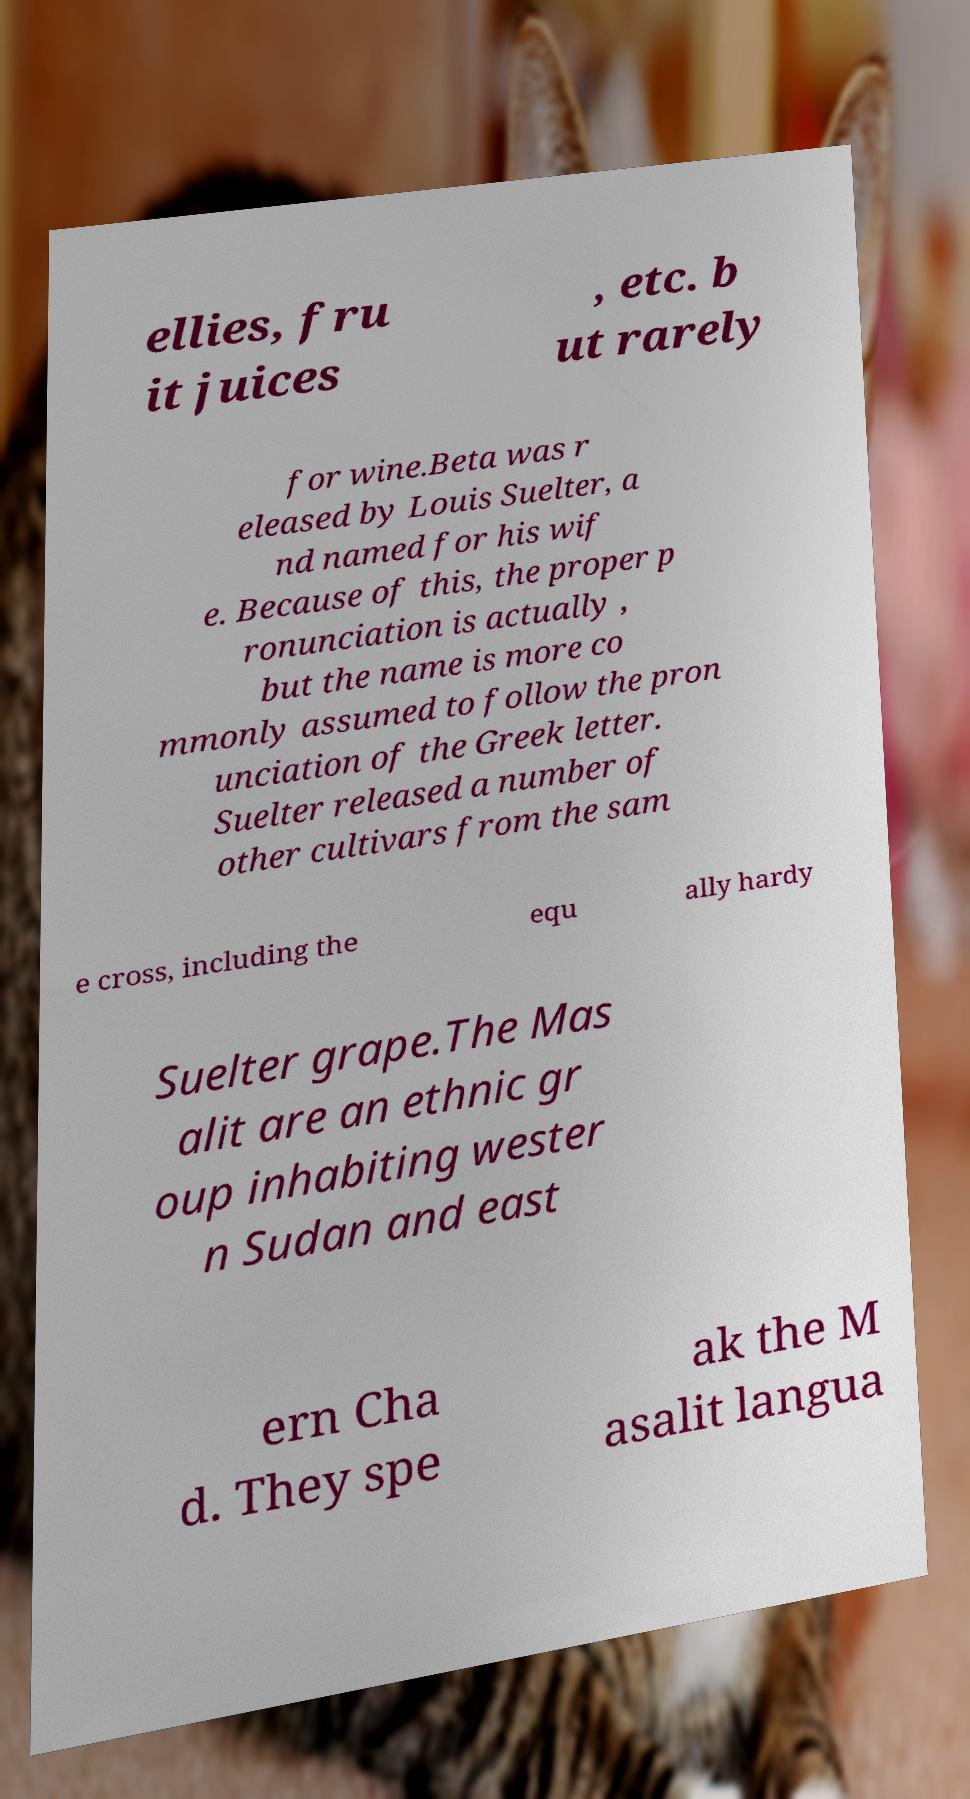Can you accurately transcribe the text from the provided image for me? ellies, fru it juices , etc. b ut rarely for wine.Beta was r eleased by Louis Suelter, a nd named for his wif e. Because of this, the proper p ronunciation is actually , but the name is more co mmonly assumed to follow the pron unciation of the Greek letter. Suelter released a number of other cultivars from the sam e cross, including the equ ally hardy Suelter grape.The Mas alit are an ethnic gr oup inhabiting wester n Sudan and east ern Cha d. They spe ak the M asalit langua 